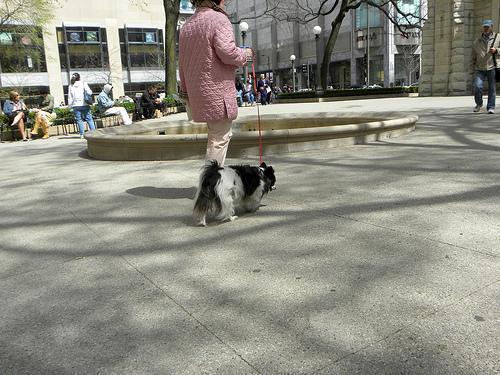How many dogs are in the picture?
Give a very brief answer. 1. 